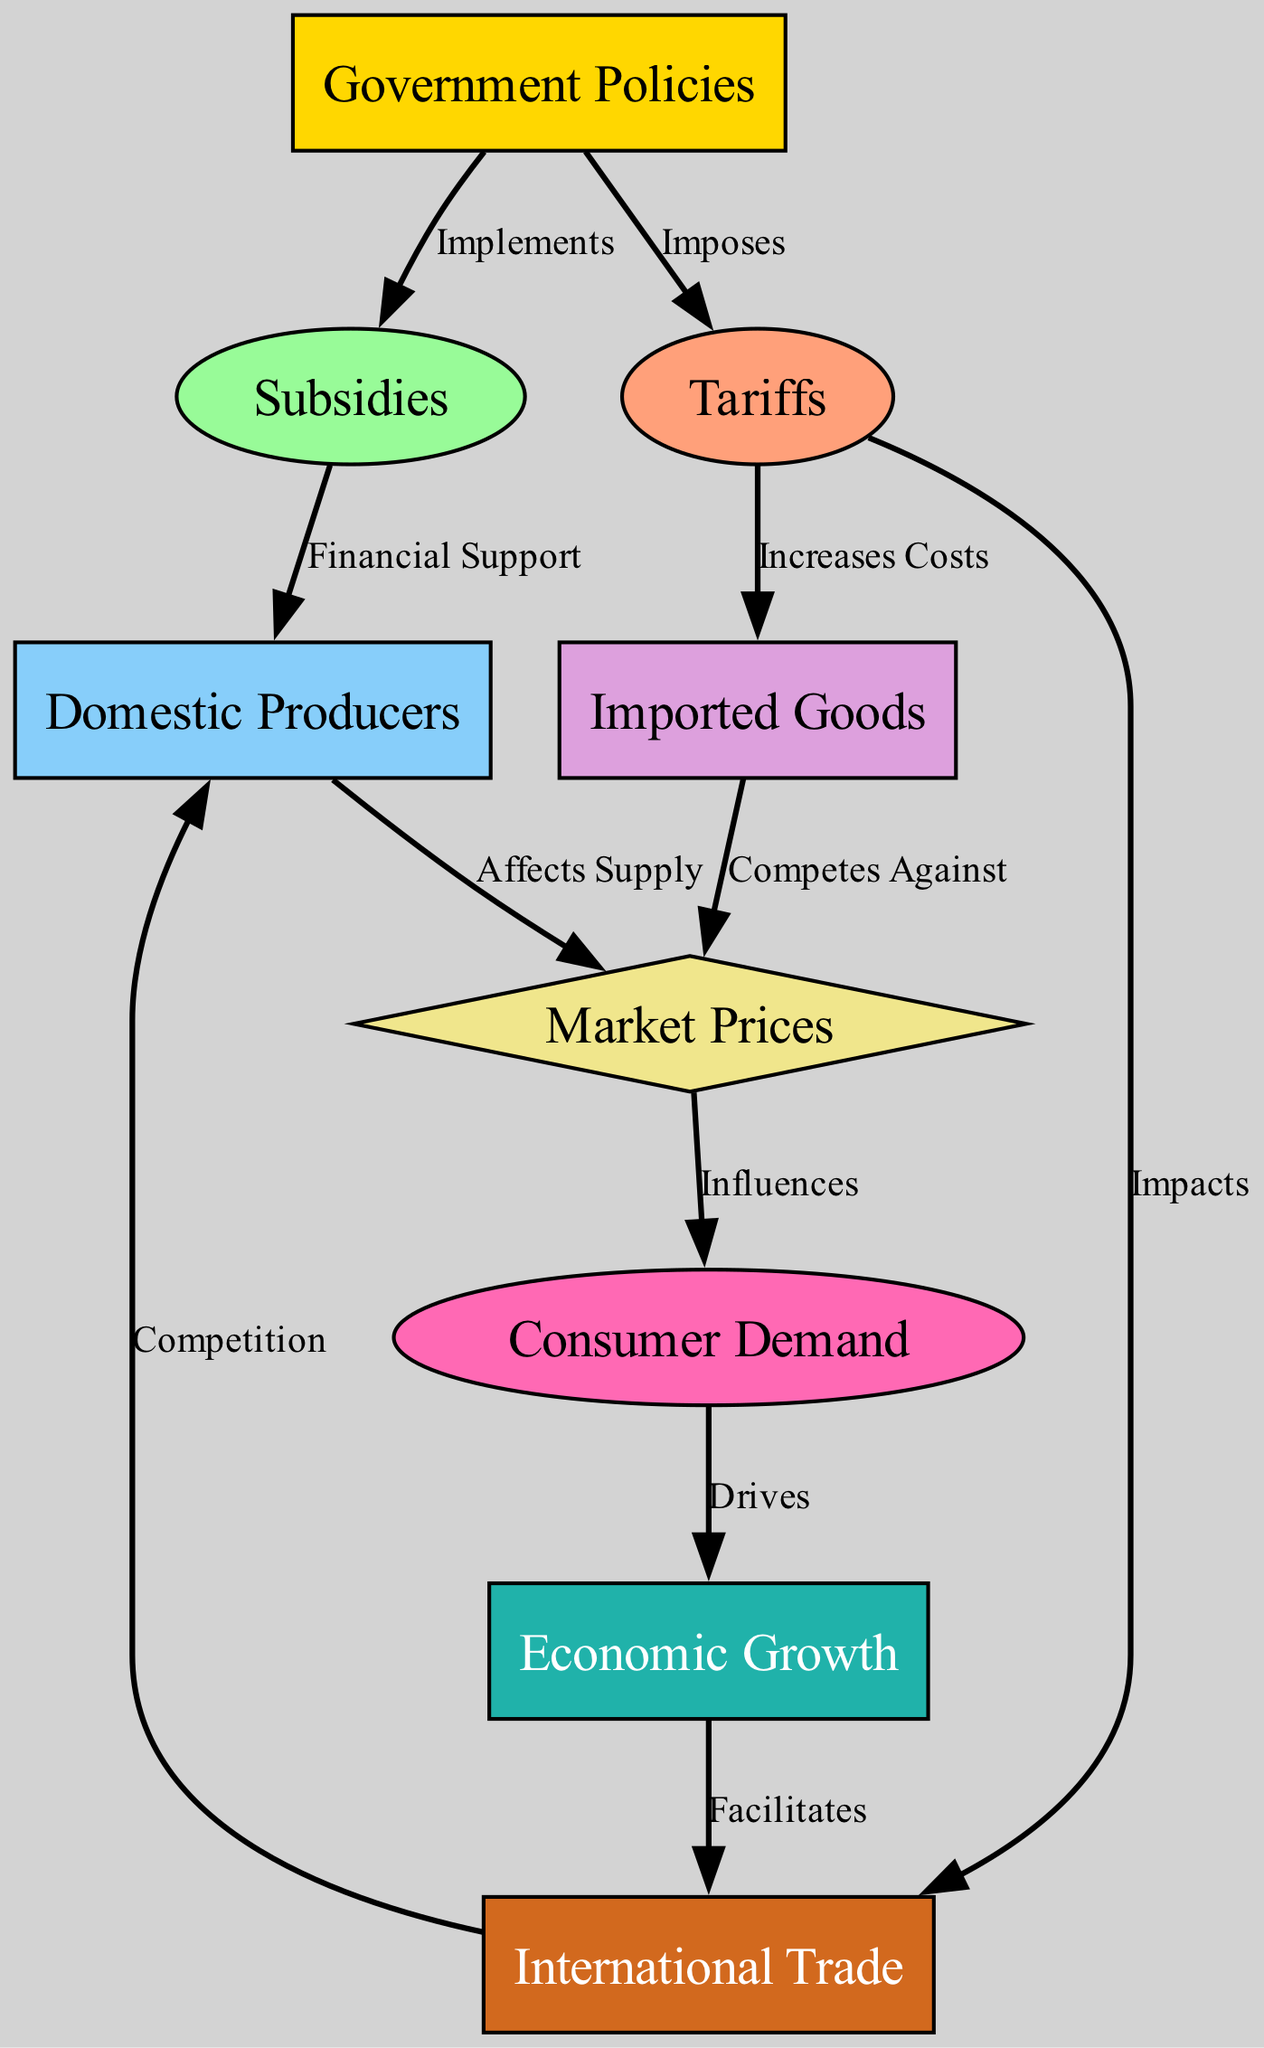What is the first node in the diagram? The first node in the diagram is "Government Policies," which is the starting point that influences other elements like subsidies and tariffs.
Answer: Government Policies How many edges are there in total? By counting the edges connecting the nodes, there are a total of 10 edges illustrating the relationships between the various factors in the food chain.
Answer: 10 What does the government implement? The government implements subsidies, which are financial support mechanisms intended for domestic producers.
Answer: Subsidies How do tariffs affect imported goods? Tariffs increase the costs associated with imported goods, thereby influencing their competitiveness in relation to domestic products.
Answer: Increases Costs What drives economic growth in this chain? Economic growth is driven by consumer demand, which affects overall market dynamics and production levels.
Answer: Consumer Demand What is the relationship between tariffs and international trade? Tariffs impact international trade by potentially restricting it due to increased costs for imported goods, which can alter trade balances and relationships.
Answer: Impacts What type of node represents market prices? Market prices are represented as a diamond-shaped node, indicating its pivotal role in influencing other factors such as consumer demand.
Answer: Diamond How do domestic producers influence prices? Domestic producers affect prices by altering supply levels in response to financial support they receive from government subsidies.
Answer: Affects Supply Which node directly competes against domestic producers? Imported goods directly compete against domestic producers, particularly when tariffs are considered, as they impact market pricing and availability.
Answer: Imported Goods What facilitates international trade? Economic growth facilitates international trade, as higher economic activity generally leads to increased exchanges with other countries.
Answer: Economic Growth 